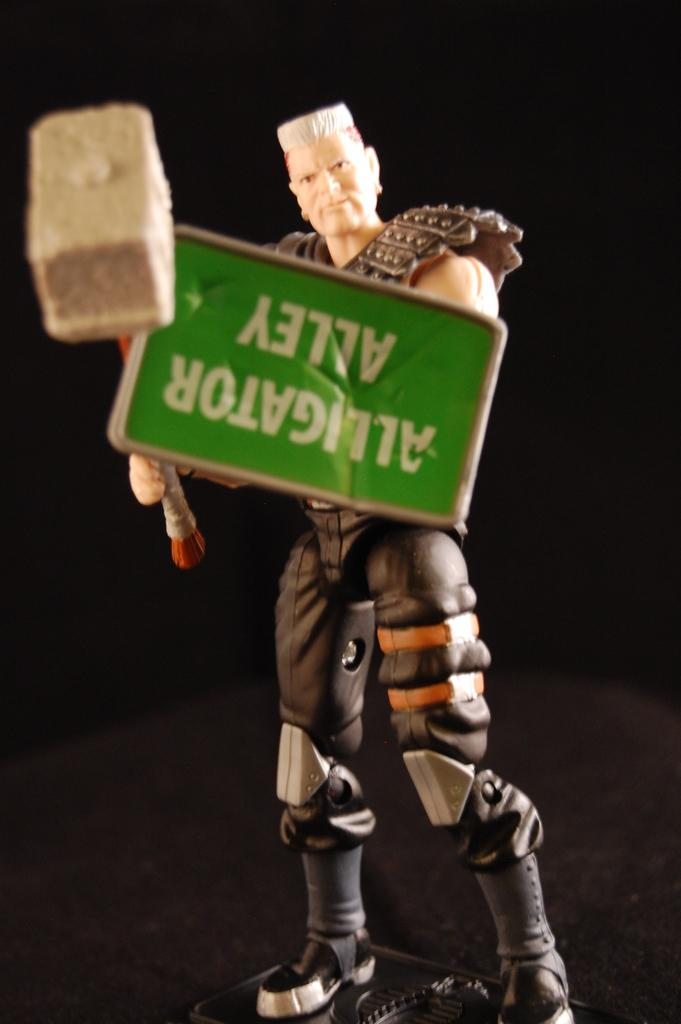What is the main object in the foreground of the picture? There is a toy in the foreground of the picture. What is the toy holding in its hands? The toy is holding a hammer and a shield board. How would you describe the overall lighting in the image? The background of the image is dark. What type of wave can be seen crashing against the shore in the image? There is no wave or shore present in the image; it features a toy holding a hammer and a shield board against a dark background. 